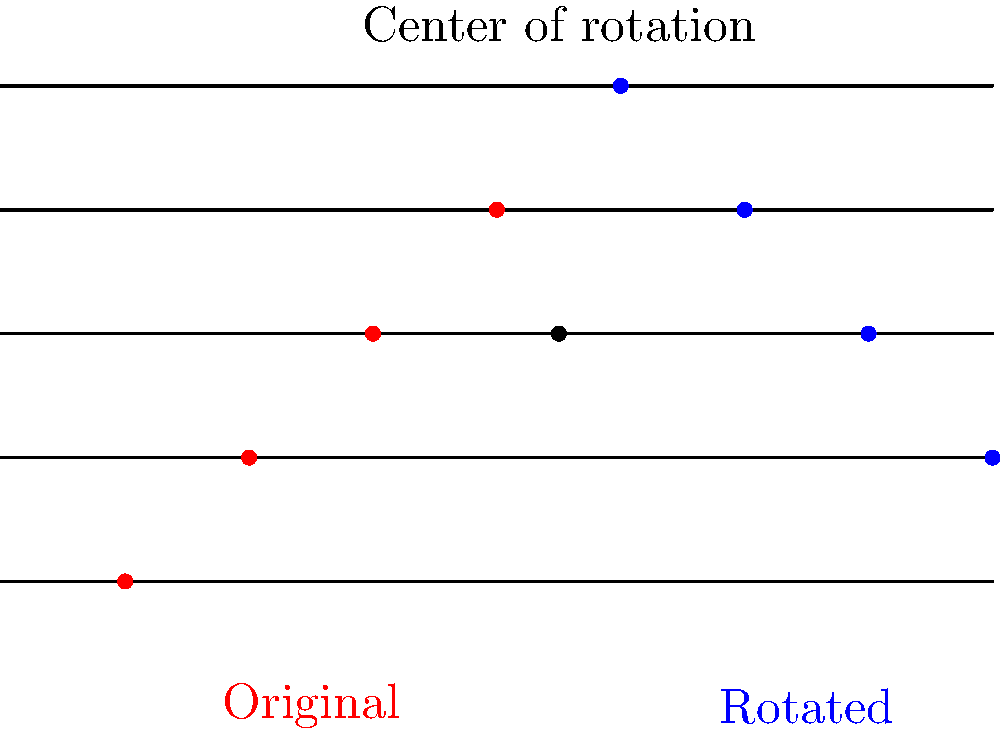In the staff above, a pattern of four notes (shown in red) has been rotated 180° around the point (4.5, 2) to create a new harmonic pattern (shown in blue). If we represent the original pattern as a vector $\mathbf{v} = [0, 1, 2, 3]$, what is the resulting vector $\mathbf{w}$ after the rotation? To solve this problem, we need to understand the effect of a 180° rotation on a vector:

1) A 180° rotation around a point (x, y) can be represented by the transformation matrix:
   $$\begin{bmatrix} -1 & 0 \\ 0 & -1 \end{bmatrix}$$

2) This transformation essentially negates both x and y coordinates relative to the center of rotation.

3) In our case, the center of rotation is at (4.5, 2) on the staff.

4) The original vector $\mathbf{v} = [0, 1, 2, 3]$ represents the vertical positions of the notes on the staff (counting from the bottom line).

5) To rotate, we first subtract the y-coordinate of the center of rotation (2) from each element of $\mathbf{v}$:
   $[0-2, 1-2, 2-2, 3-2] = [-2, -1, 0, 1]$

6) Then we negate each element (equivalent to multiplying by -1):
   $-[-2, -1, 0, 1] = [2, 1, 0, -1]$

7) Finally, we add back the y-coordinate of the center of rotation:
   $[2+2, 1+2, 0+2, -1+2] = [4, 3, 2, 1]$

8) This resulting vector $\mathbf{w} = [4, 3, 2, 1]$ represents the vertical positions of the rotated notes (blue dots) on the staff, counting from the bottom line.
Answer: $\mathbf{w} = [4, 3, 2, 1]$ 